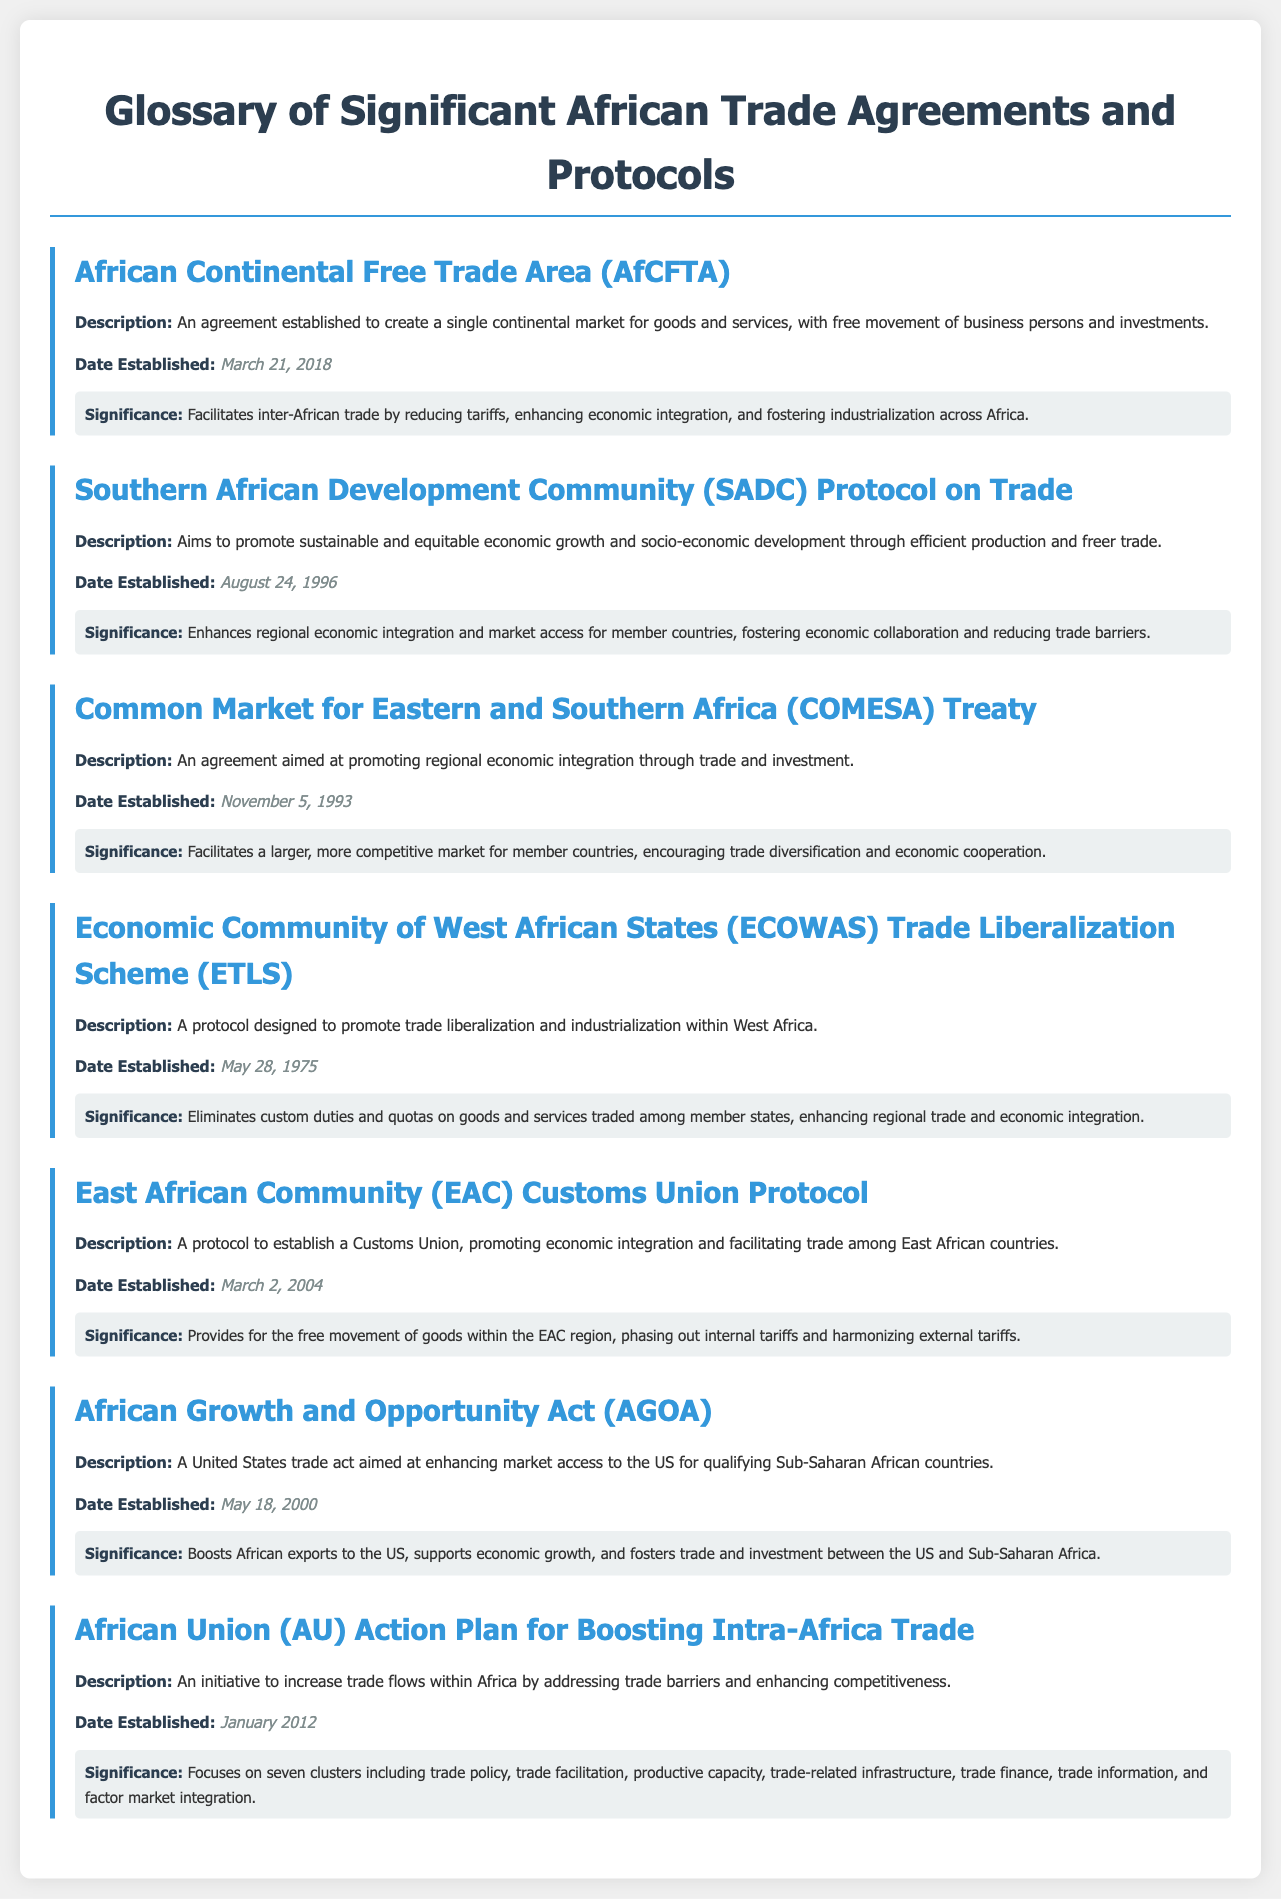What is the African Continental Free Trade Area? The African Continental Free Trade Area is an agreement established to create a single continental market for goods and services, with free movement of business persons and investments.
Answer: A single continental market for goods and services When was the Southern African Development Community Protocol on Trade established? The date established for the Southern African Development Community Protocol on Trade is mentioned in the document.
Answer: August 24, 1996 What is the main goal of the Economic Community of West African States Trade Liberalization Scheme? The main goal is to promote trade liberalization and industrialization within West Africa.
Answer: Promote trade liberalization and industrialization What significant benefit does the AfCFTA provide? The significance discusses how the AfCFTA facilitates inter-African trade by reducing tariffs and enhancing economic integration.
Answer: Reducing tariffs and enhancing economic integration Which agreement focuses on boosting intra-Africa trade? The document lists the title of the initiative aimed at increasing trade flows within Africa.
Answer: African Union Action Plan for Boosting Intra-Africa Trade What year was the African Growth and Opportunity Act established? The document specifies the date established for the African Growth and Opportunity Act.
Answer: May 18, 2000 What is the significance of the Common Market for Eastern and Southern Africa Treaty? The significance describes how the treaty facilitates a larger, more competitive market for member countries.
Answer: Facilitates a larger, more competitive market Which protocol promotes economic integration among East African countries? The title of the protocol that promotes economic integration outlines its focus.
Answer: East African Community Customs Union Protocol 